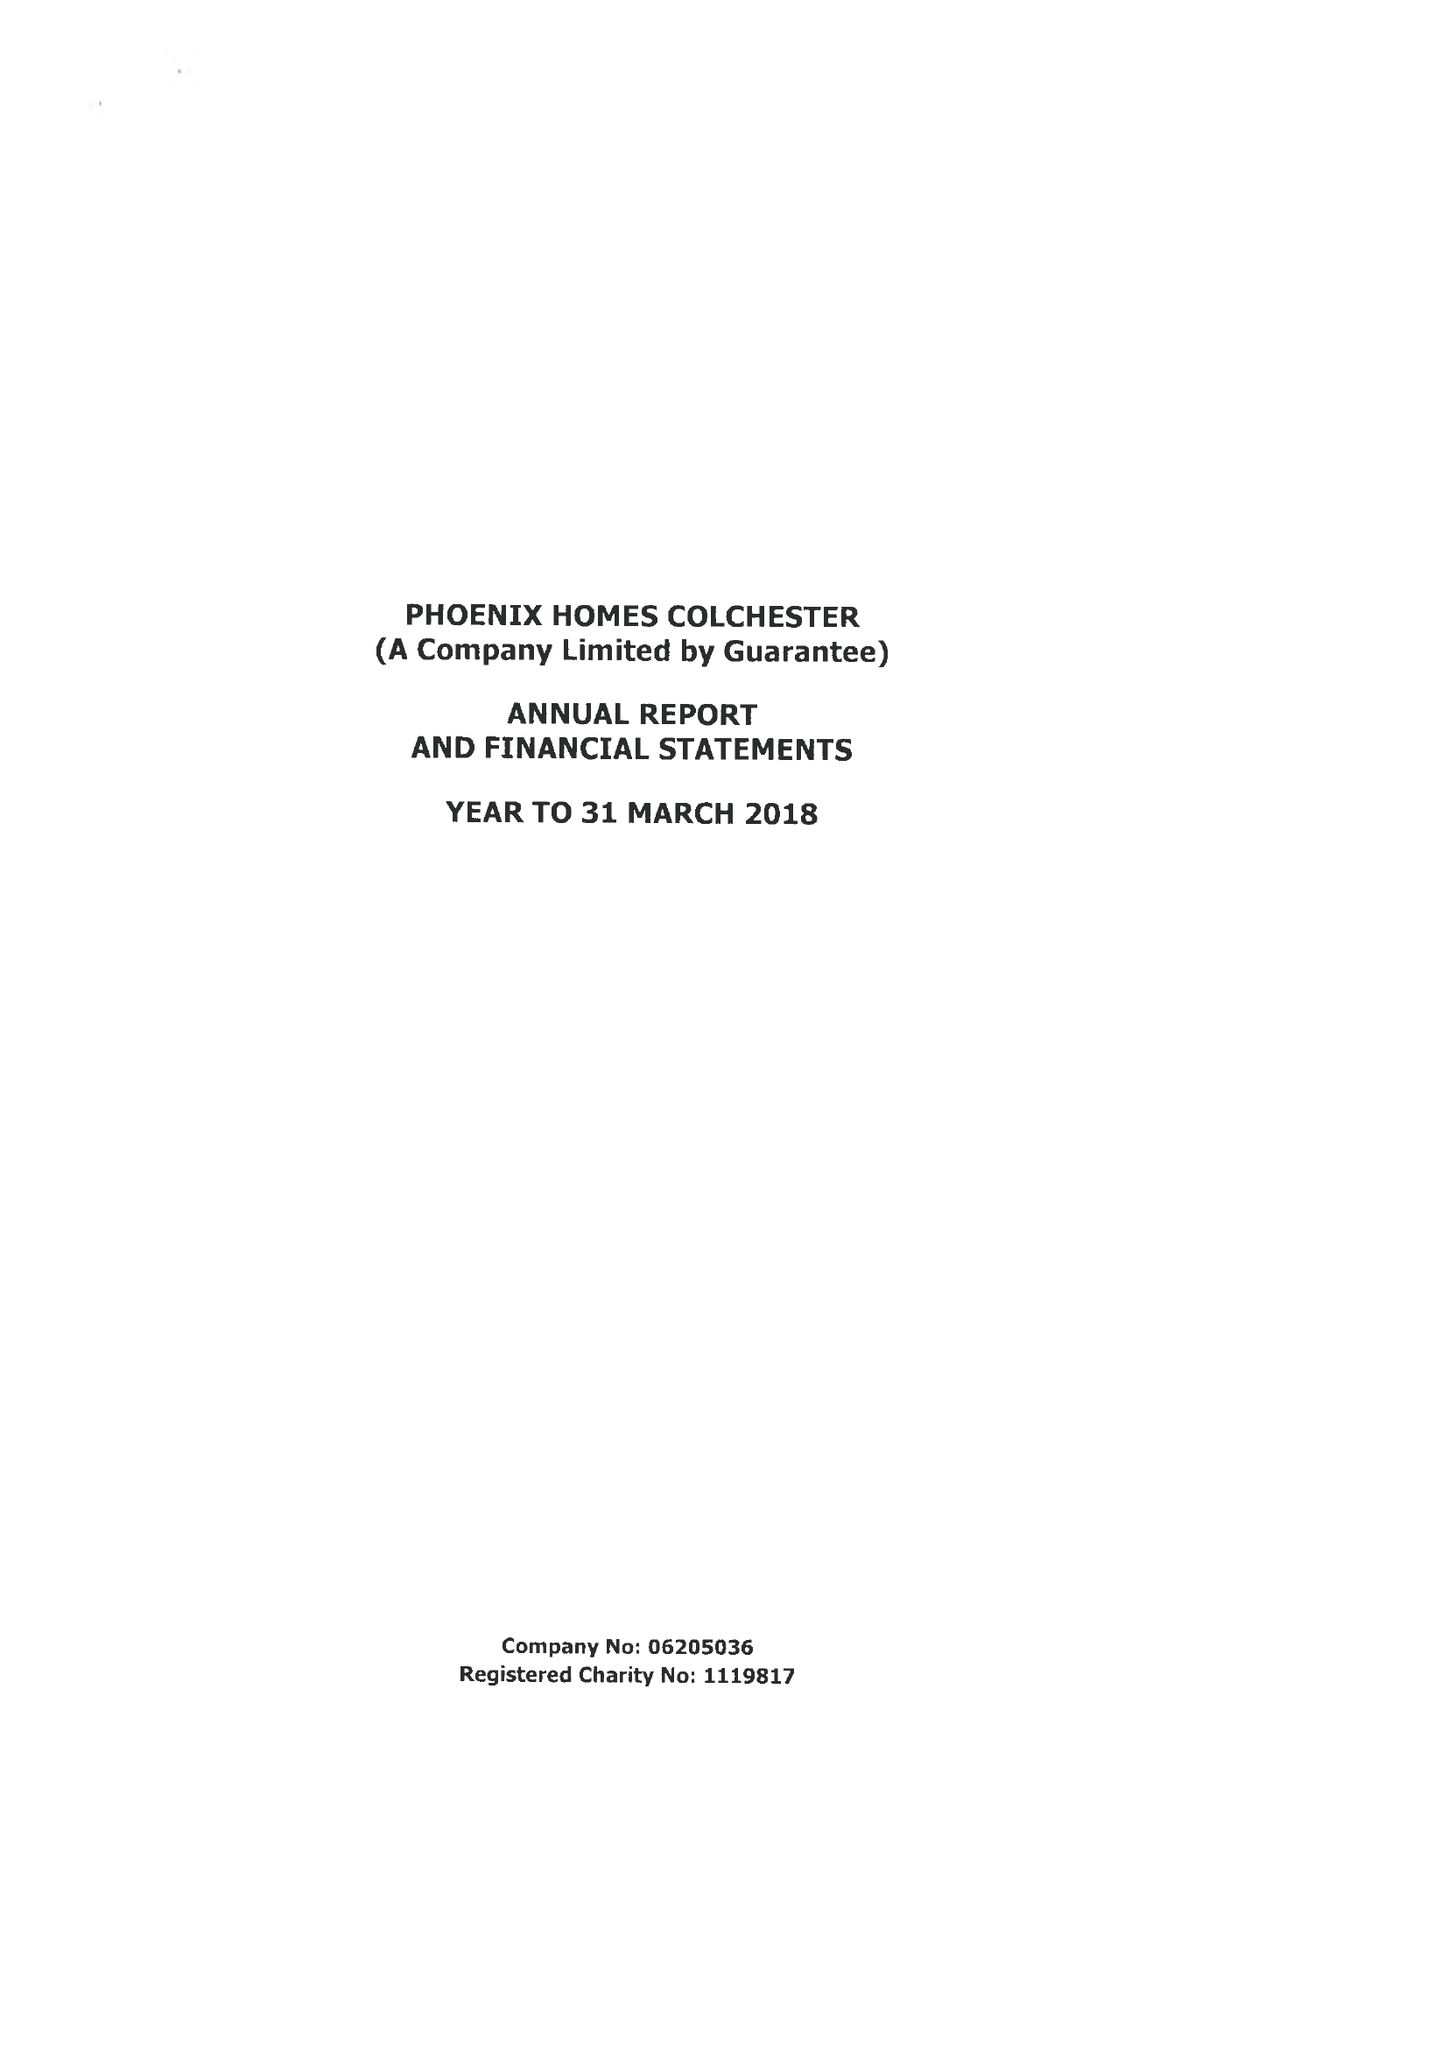What is the value for the address__street_line?
Answer the question using a single word or phrase. 147 STRAIGHT ROAD 